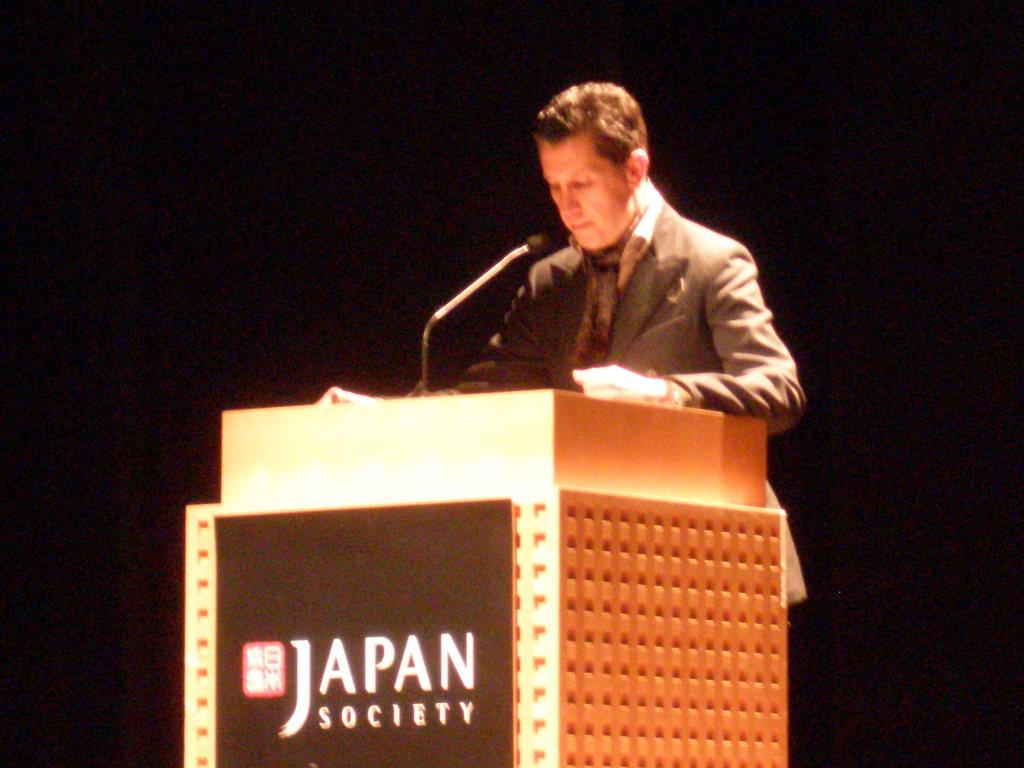What is the person in the image doing? The person is standing in front of a podium. What can be seen on the podium? There is text visible on the podium, and there is a microphone on the podium. How would you describe the lighting in the image? The background of the image is dark. How many eggs are on the desk in the image? There is no desk or eggs present in the image. What type of ground can be seen through the window in the image? There is no window or ground visible in the image. 